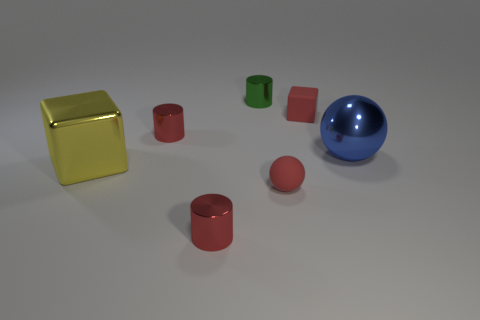Subtract all yellow balls. Subtract all green cylinders. How many balls are left? 2 Add 3 gray metallic spheres. How many objects exist? 10 Subtract all blocks. How many objects are left? 5 Add 1 tiny purple objects. How many tiny purple objects exist? 1 Subtract 0 cyan cylinders. How many objects are left? 7 Subtract all metallic spheres. Subtract all yellow cubes. How many objects are left? 5 Add 2 small cylinders. How many small cylinders are left? 5 